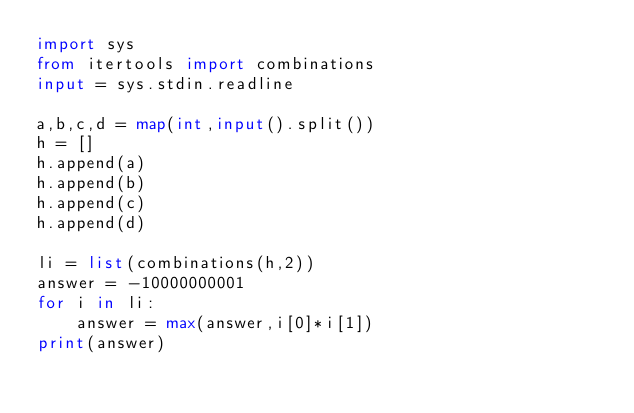<code> <loc_0><loc_0><loc_500><loc_500><_Python_>import sys
from itertools import combinations
input = sys.stdin.readline

a,b,c,d = map(int,input().split())
h = []
h.append(a)
h.append(b)
h.append(c)
h.append(d)

li = list(combinations(h,2))
answer = -10000000001
for i in li:
    answer = max(answer,i[0]*i[1])
print(answer)</code> 